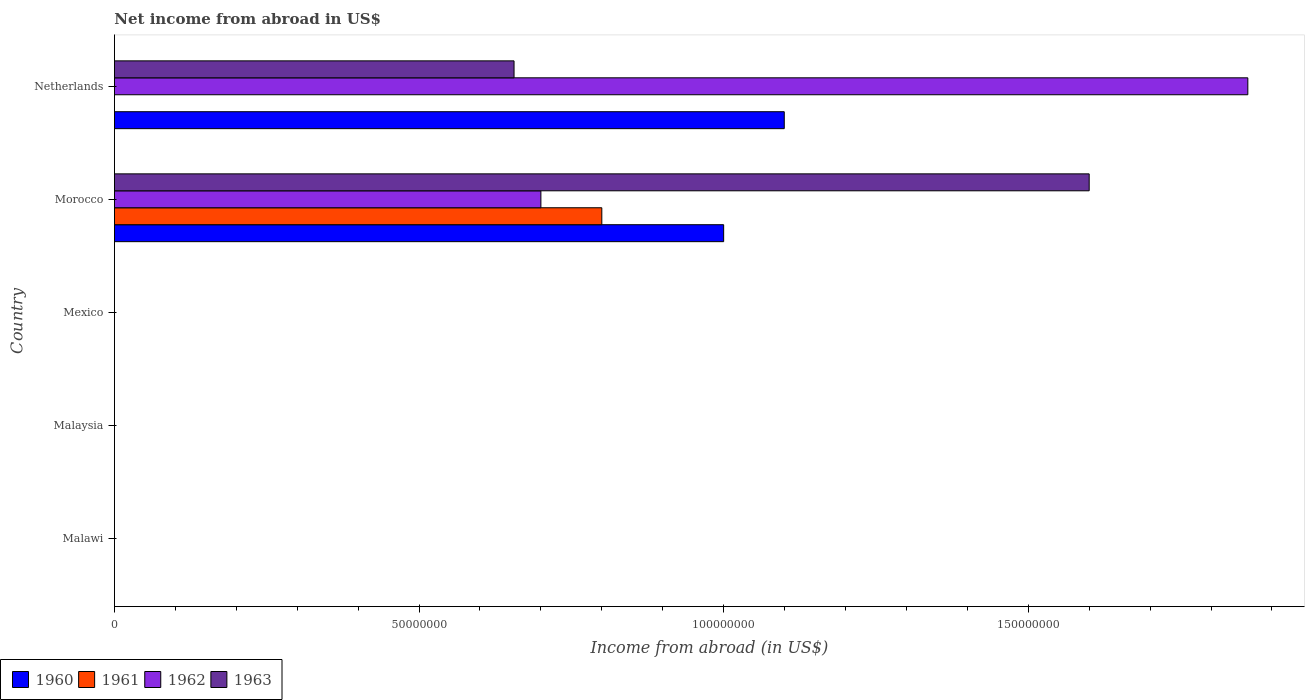How many different coloured bars are there?
Make the answer very short. 4. How many bars are there on the 5th tick from the bottom?
Your answer should be compact. 3. What is the label of the 2nd group of bars from the top?
Keep it short and to the point. Morocco. In how many cases, is the number of bars for a given country not equal to the number of legend labels?
Make the answer very short. 4. What is the net income from abroad in 1961 in Malaysia?
Keep it short and to the point. 0. Across all countries, what is the maximum net income from abroad in 1961?
Your response must be concise. 8.00e+07. Across all countries, what is the minimum net income from abroad in 1962?
Your answer should be very brief. 0. In which country was the net income from abroad in 1960 maximum?
Provide a succinct answer. Netherlands. What is the total net income from abroad in 1961 in the graph?
Make the answer very short. 8.00e+07. What is the difference between the net income from abroad in 1960 in Morocco and that in Netherlands?
Your answer should be compact. -9.95e+06. What is the average net income from abroad in 1961 per country?
Give a very brief answer. 1.60e+07. What is the difference between the net income from abroad in 1961 and net income from abroad in 1963 in Morocco?
Your answer should be very brief. -8.00e+07. What is the ratio of the net income from abroad in 1962 in Morocco to that in Netherlands?
Your response must be concise. 0.38. What is the difference between the highest and the lowest net income from abroad in 1961?
Your response must be concise. 8.00e+07. Is the sum of the net income from abroad in 1963 in Morocco and Netherlands greater than the maximum net income from abroad in 1962 across all countries?
Give a very brief answer. Yes. Is it the case that in every country, the sum of the net income from abroad in 1962 and net income from abroad in 1961 is greater than the sum of net income from abroad in 1960 and net income from abroad in 1963?
Keep it short and to the point. No. Are all the bars in the graph horizontal?
Offer a very short reply. Yes. Does the graph contain any zero values?
Provide a succinct answer. Yes. Where does the legend appear in the graph?
Provide a succinct answer. Bottom left. How many legend labels are there?
Provide a short and direct response. 4. How are the legend labels stacked?
Your answer should be very brief. Horizontal. What is the title of the graph?
Your response must be concise. Net income from abroad in US$. Does "1985" appear as one of the legend labels in the graph?
Your response must be concise. No. What is the label or title of the X-axis?
Give a very brief answer. Income from abroad (in US$). What is the Income from abroad (in US$) of 1961 in Malawi?
Your answer should be compact. 0. What is the Income from abroad (in US$) of 1963 in Malawi?
Offer a very short reply. 0. What is the Income from abroad (in US$) of 1963 in Mexico?
Offer a very short reply. 0. What is the Income from abroad (in US$) in 1960 in Morocco?
Your answer should be very brief. 1.00e+08. What is the Income from abroad (in US$) of 1961 in Morocco?
Offer a very short reply. 8.00e+07. What is the Income from abroad (in US$) of 1962 in Morocco?
Provide a short and direct response. 7.00e+07. What is the Income from abroad (in US$) of 1963 in Morocco?
Your answer should be compact. 1.60e+08. What is the Income from abroad (in US$) of 1960 in Netherlands?
Provide a short and direct response. 1.10e+08. What is the Income from abroad (in US$) of 1961 in Netherlands?
Offer a very short reply. 0. What is the Income from abroad (in US$) in 1962 in Netherlands?
Offer a terse response. 1.86e+08. What is the Income from abroad (in US$) of 1963 in Netherlands?
Your answer should be compact. 6.56e+07. Across all countries, what is the maximum Income from abroad (in US$) in 1960?
Provide a short and direct response. 1.10e+08. Across all countries, what is the maximum Income from abroad (in US$) in 1961?
Your answer should be very brief. 8.00e+07. Across all countries, what is the maximum Income from abroad (in US$) in 1962?
Offer a terse response. 1.86e+08. Across all countries, what is the maximum Income from abroad (in US$) of 1963?
Your answer should be very brief. 1.60e+08. Across all countries, what is the minimum Income from abroad (in US$) in 1962?
Make the answer very short. 0. Across all countries, what is the minimum Income from abroad (in US$) of 1963?
Your response must be concise. 0. What is the total Income from abroad (in US$) in 1960 in the graph?
Make the answer very short. 2.10e+08. What is the total Income from abroad (in US$) in 1961 in the graph?
Provide a succinct answer. 8.00e+07. What is the total Income from abroad (in US$) of 1962 in the graph?
Offer a terse response. 2.56e+08. What is the total Income from abroad (in US$) of 1963 in the graph?
Offer a very short reply. 2.26e+08. What is the difference between the Income from abroad (in US$) in 1960 in Morocco and that in Netherlands?
Provide a short and direct response. -9.95e+06. What is the difference between the Income from abroad (in US$) in 1962 in Morocco and that in Netherlands?
Ensure brevity in your answer.  -1.16e+08. What is the difference between the Income from abroad (in US$) of 1963 in Morocco and that in Netherlands?
Ensure brevity in your answer.  9.44e+07. What is the difference between the Income from abroad (in US$) in 1960 in Morocco and the Income from abroad (in US$) in 1962 in Netherlands?
Keep it short and to the point. -8.60e+07. What is the difference between the Income from abroad (in US$) in 1960 in Morocco and the Income from abroad (in US$) in 1963 in Netherlands?
Provide a short and direct response. 3.44e+07. What is the difference between the Income from abroad (in US$) in 1961 in Morocco and the Income from abroad (in US$) in 1962 in Netherlands?
Keep it short and to the point. -1.06e+08. What is the difference between the Income from abroad (in US$) in 1961 in Morocco and the Income from abroad (in US$) in 1963 in Netherlands?
Offer a terse response. 1.44e+07. What is the difference between the Income from abroad (in US$) in 1962 in Morocco and the Income from abroad (in US$) in 1963 in Netherlands?
Make the answer very short. 4.41e+06. What is the average Income from abroad (in US$) in 1960 per country?
Provide a succinct answer. 4.20e+07. What is the average Income from abroad (in US$) of 1961 per country?
Offer a very short reply. 1.60e+07. What is the average Income from abroad (in US$) of 1962 per country?
Provide a succinct answer. 5.12e+07. What is the average Income from abroad (in US$) in 1963 per country?
Give a very brief answer. 4.51e+07. What is the difference between the Income from abroad (in US$) in 1960 and Income from abroad (in US$) in 1961 in Morocco?
Provide a short and direct response. 2.00e+07. What is the difference between the Income from abroad (in US$) of 1960 and Income from abroad (in US$) of 1962 in Morocco?
Make the answer very short. 3.00e+07. What is the difference between the Income from abroad (in US$) of 1960 and Income from abroad (in US$) of 1963 in Morocco?
Offer a very short reply. -6.00e+07. What is the difference between the Income from abroad (in US$) in 1961 and Income from abroad (in US$) in 1962 in Morocco?
Make the answer very short. 1.00e+07. What is the difference between the Income from abroad (in US$) of 1961 and Income from abroad (in US$) of 1963 in Morocco?
Keep it short and to the point. -8.00e+07. What is the difference between the Income from abroad (in US$) of 1962 and Income from abroad (in US$) of 1963 in Morocco?
Your answer should be very brief. -9.00e+07. What is the difference between the Income from abroad (in US$) of 1960 and Income from abroad (in US$) of 1962 in Netherlands?
Your answer should be very brief. -7.61e+07. What is the difference between the Income from abroad (in US$) of 1960 and Income from abroad (in US$) of 1963 in Netherlands?
Offer a terse response. 4.44e+07. What is the difference between the Income from abroad (in US$) of 1962 and Income from abroad (in US$) of 1963 in Netherlands?
Provide a short and direct response. 1.20e+08. What is the ratio of the Income from abroad (in US$) in 1960 in Morocco to that in Netherlands?
Give a very brief answer. 0.91. What is the ratio of the Income from abroad (in US$) in 1962 in Morocco to that in Netherlands?
Offer a very short reply. 0.38. What is the ratio of the Income from abroad (in US$) in 1963 in Morocco to that in Netherlands?
Offer a very short reply. 2.44. What is the difference between the highest and the lowest Income from abroad (in US$) in 1960?
Provide a succinct answer. 1.10e+08. What is the difference between the highest and the lowest Income from abroad (in US$) in 1961?
Give a very brief answer. 8.00e+07. What is the difference between the highest and the lowest Income from abroad (in US$) of 1962?
Provide a short and direct response. 1.86e+08. What is the difference between the highest and the lowest Income from abroad (in US$) of 1963?
Your answer should be very brief. 1.60e+08. 